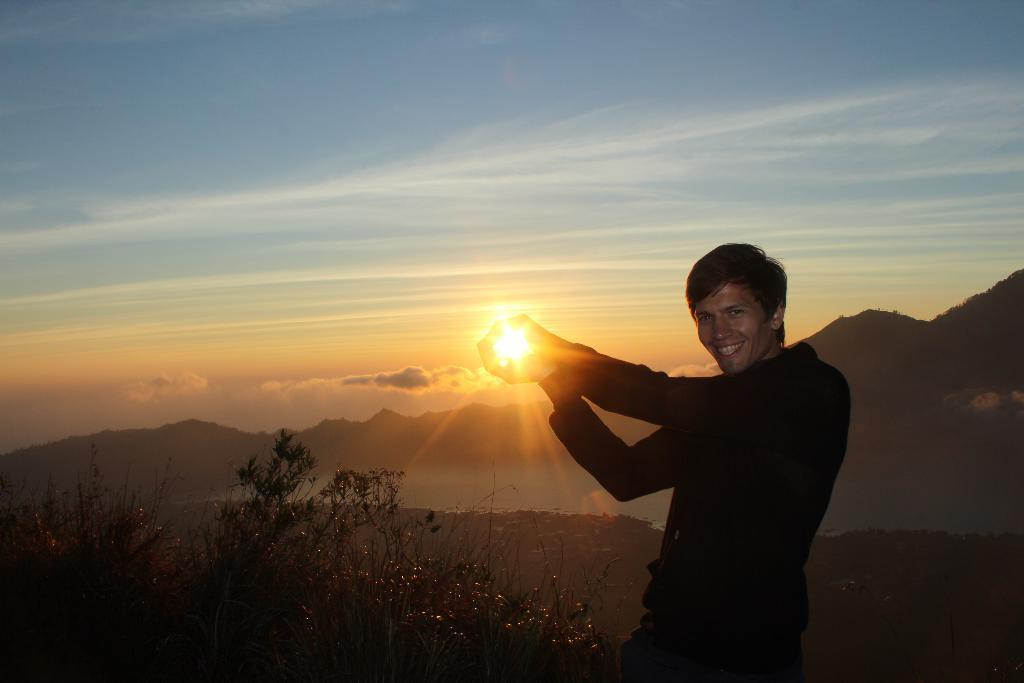What is the main subject of the image? There is a person standing in the image. What is the person wearing? The person is wearing a black dress. What can be seen in the background of the image? There are plants and mountains in the background of the image. How would you describe the sky in the image? The sky is visible in the image, and it has blue, white, and orange colors. What type of screw can be seen in the person's hand in the image? There is no screw present in the image; the person is not holding anything. Is the person stretching in the image? The image does not provide information about the person's actions or posture, so it cannot be determined if they are stretching. 